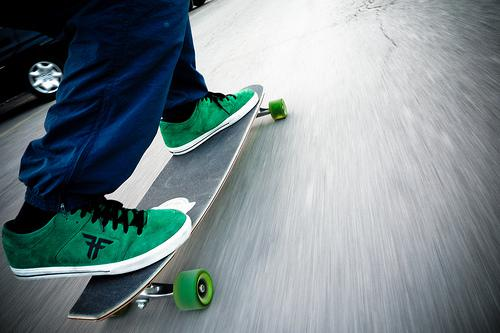Question: what surface is the skateboard on?
Choices:
A. Metal rail.
B. Asphalt.
C. Hook.
D. Board.
Answer with the letter. Answer: B Question: when was this image taken?
Choices:
A. At Christmas.
B. Daytime.
C. Sunrise.
D. Dusk.
Answer with the letter. Answer: B 